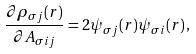<formula> <loc_0><loc_0><loc_500><loc_500>\frac { \partial \rho _ { \sigma j } ( { r } ) } { \partial A _ { \sigma i j } } = 2 \psi _ { \sigma j } ( { r } ) \psi _ { \sigma i } ( { r } ) \, ,</formula> 